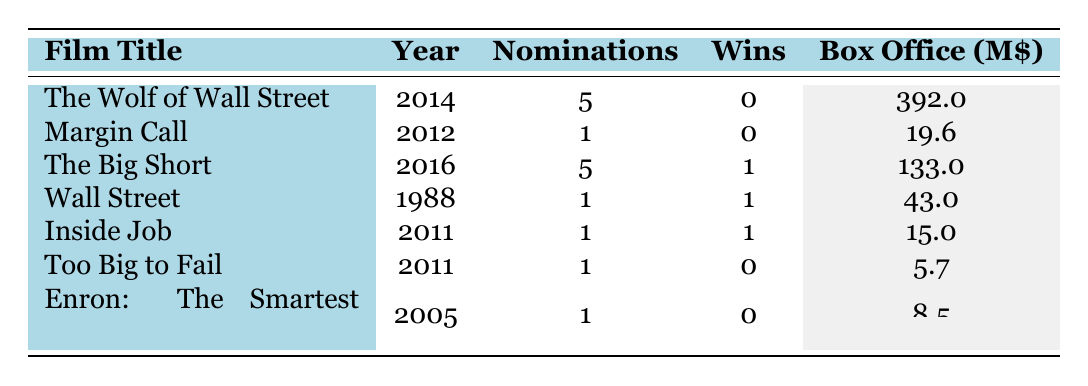What film had the highest box office gross? The film with the highest box office gross is "The Wolf of Wall Street," which grossed $392 million.
Answer: The Wolf of Wall Street How many films won at least one Oscar? "The Big Short," "Wall Street," and "Inside Job" each won one Oscar, totaling three movies that received at least one win.
Answer: 3 What is the average number of nominations for the films listed? Summing the nominations gives 5 + 1 + 5 + 1 + 1 + 1 + 1 = 15. There are 7 films, so the average is 15/7 ≈ 2.14.
Answer: Approximately 2.14 Which documentarian film was nominated for an Oscar? Both "Inside Job" and "Enron: The Smartest Guys in the Room" are documentary films that received nominations.
Answer: Inside Job, Enron: The Smartest Guys in the Room What is the difference in box office gross between "The Big Short" and "Margin Call"? "The Big Short" grossed $133 million and "Margin Call" grossed $19.6 million. The difference is 133 - 19.6 = 113.4 million.
Answer: 113.4 million Did any film with more than 3 nominations win an Oscar? "The Big Short," with five nominations, won one Oscar, so yes, there was a film with more than three nominations that won an Oscar.
Answer: Yes What is the total box office gross for all films combined? Summing the box office gross of each film: 392 + 19.6 + 133 + 43 + 15 + 5.7 + 8.5 = 617.8 million.
Answer: 617.8 million Which film has the same number of nominations and wins? "Wall Street," "Inside Job," and "Too Big to Fail" each have one nomination and one win.
Answer: Wall Street, Inside Job, Too Big to Fail Is there a film that reflects the theme of "corporate greed" that won an Oscar? Yes, "Wall Street" reflects the theme of corporate greed and has one Oscar win.
Answer: Yes Among the films listed, which film was directed by Martin Scorsese? "The Wolf of Wall Street" was directed by Martin Scorsese.
Answer: The Wolf of Wall Street 